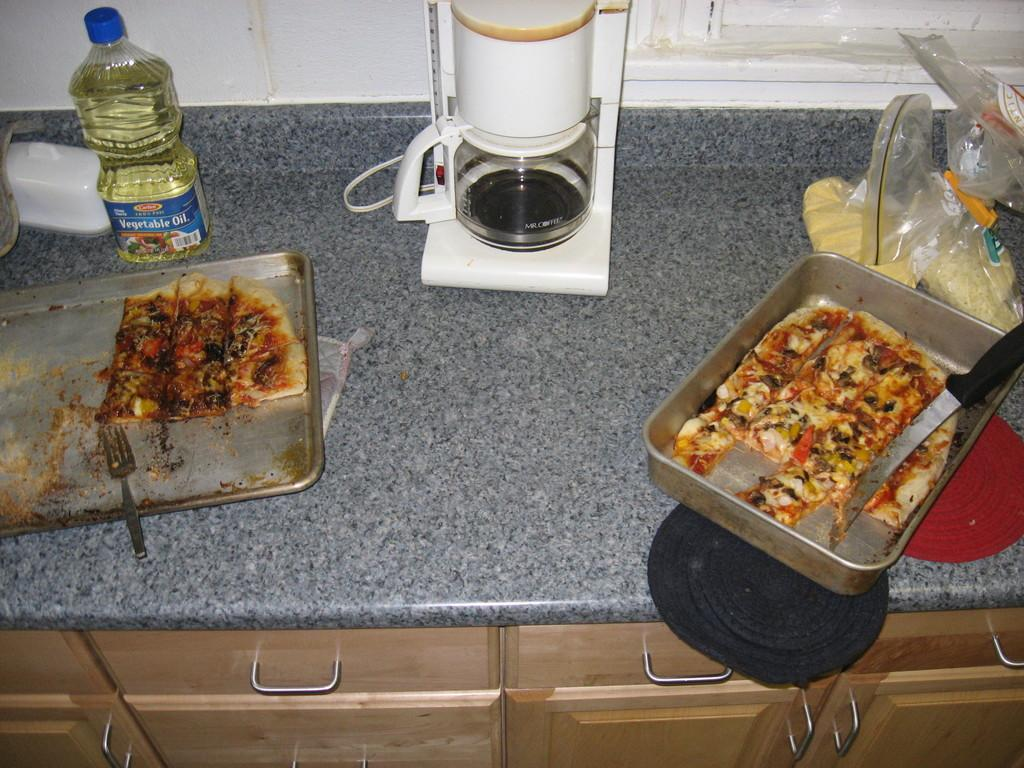Provide a one-sentence caption for the provided image. A bottle of Vegetable Oild beside a half eated pizza in a pan on a countertop. 